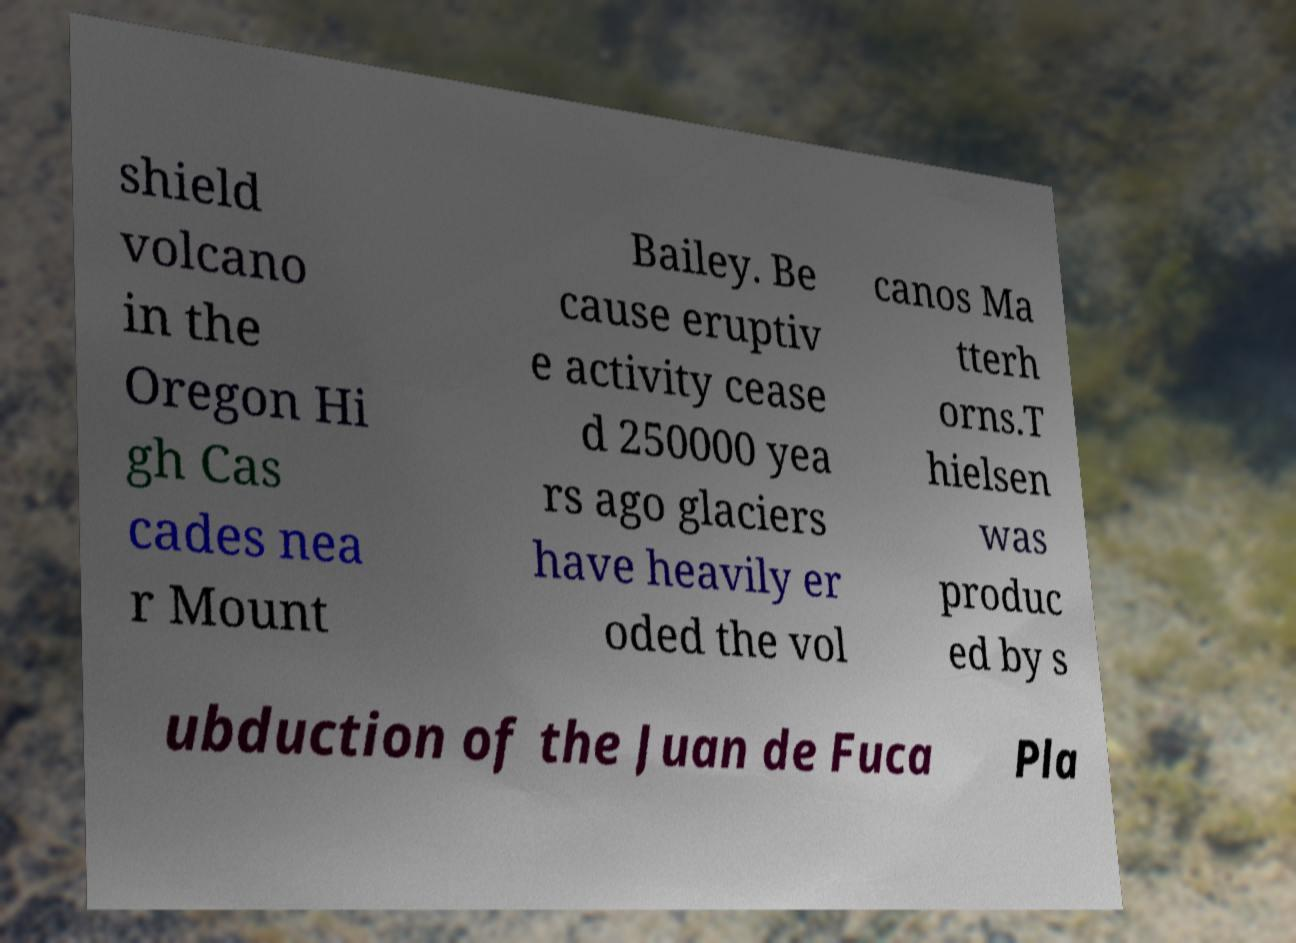What messages or text are displayed in this image? I need them in a readable, typed format. shield volcano in the Oregon Hi gh Cas cades nea r Mount Bailey. Be cause eruptiv e activity cease d 250000 yea rs ago glaciers have heavily er oded the vol canos Ma tterh orns.T hielsen was produc ed by s ubduction of the Juan de Fuca Pla 